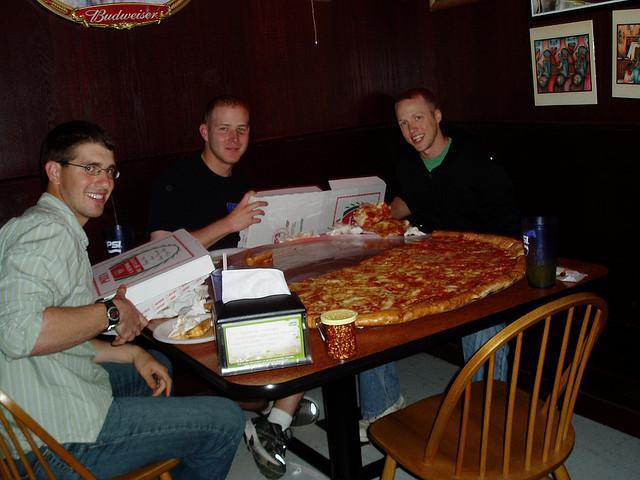How many people are at the table?
Give a very brief answer. 3. How many people are there?
Give a very brief answer. 3. How many chairs can you see?
Give a very brief answer. 2. How many trains are at the train station?
Give a very brief answer. 0. 